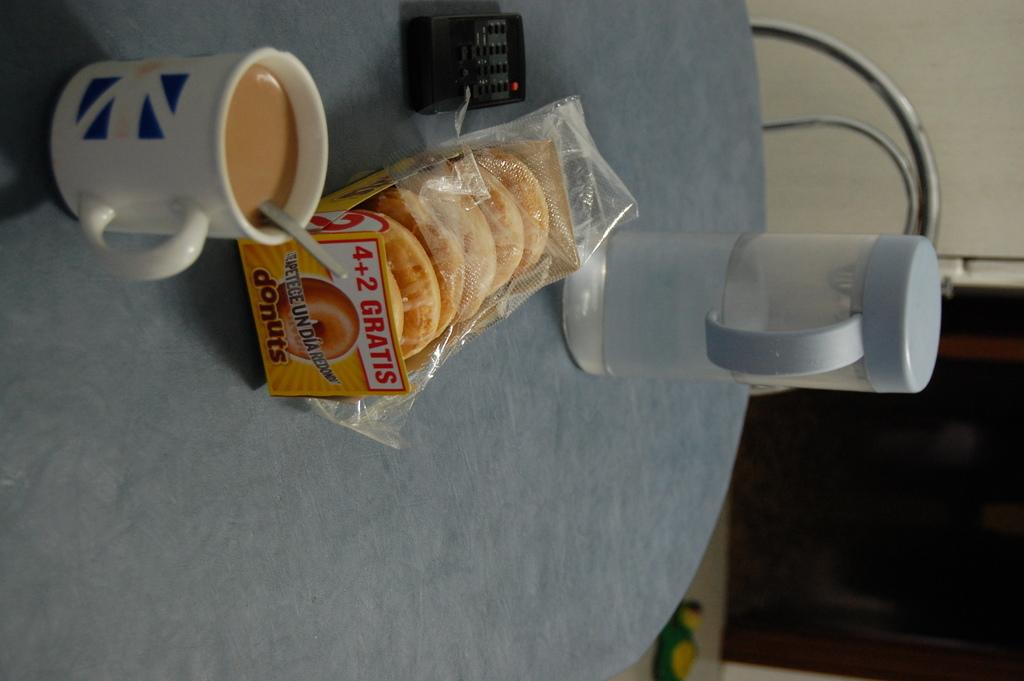What kind of pastry is in the packaging?
Give a very brief answer. Donuts. How many donuts are in the package?
Make the answer very short. 6. 